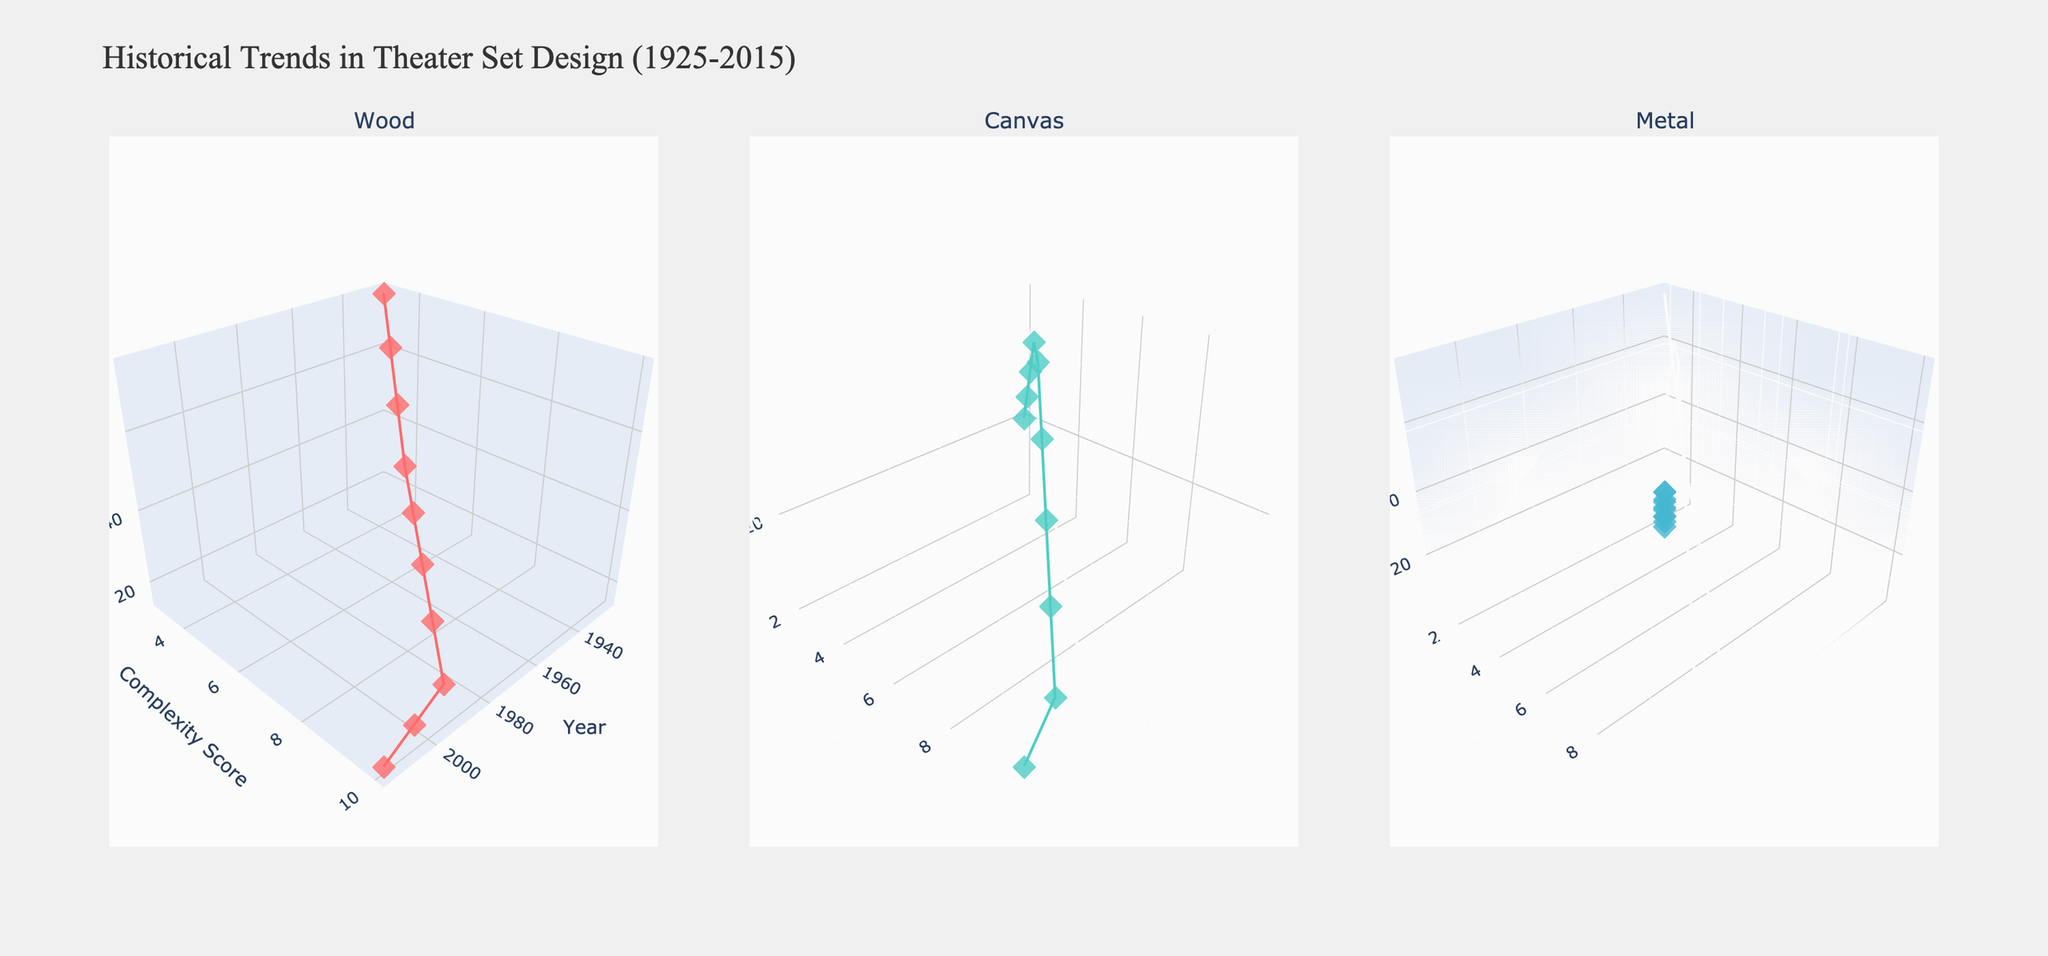How does the complexity score for wood set designs change from the 1920s to the 2010s? By examining the subplot for wood, the complexity score increases steadily from 3 in the 1920s to 10 in the 2010s. This shows a consistent rise in complexity over the decades.
Answer: It increases Which material had the highest usage percentage in the 2010s? By looking at the 2010s data points for each material subplot, metal had the highest usage percentage of 75%. The other materials, wood and canvas, had lower percentages of 15% and 10% respectively.
Answer: Metal What is the relationship between the complexity score and usage percentage for metal in the 2000s? For the 2000s, in the metal subplot, the data point shows a complexity score of 9 and a usage percentage of 65%. Thus, as the complexity score increased, the usage percentage was quite high.
Answer: Positive correlation Which decade shows the largest increase in complexity score for canvas? By checking the canvas subplot, the increase in complexity score is most notable between the 1990s and the 2000s, where it jumps from 9 to 10.
Answer: 1990s to 2000s How did the material usage percentages for wood and metal compare in the 1960s? In the 1960s, the usage percentage for wood was 40% and for metal was 25% based on their respective subplots. Wood was used more than metal.
Answer: Wood > Metal Considering the overall trends, which material shows the most significant increase in usage percentage over time? By evaluating all subplots, metal shows the most significant increase in usage percentage from 5% in the 1920s to 75% in the 2010s, a 70% increase.
Answer: Metal What pattern can be seen in the usage percentage of canvas from the 1980s to the 2010s? From the canvas subplot, the usage percentage declines from 25% in the 1980s to 10% in the 2010s, showing a downward trend.
Answer: Decline Is there a decade in which the complexity scores for all three materials are the same? By scanning the subplots, only in the 2010s do all materials have a complexity score of 10.
Answer: 2010s 